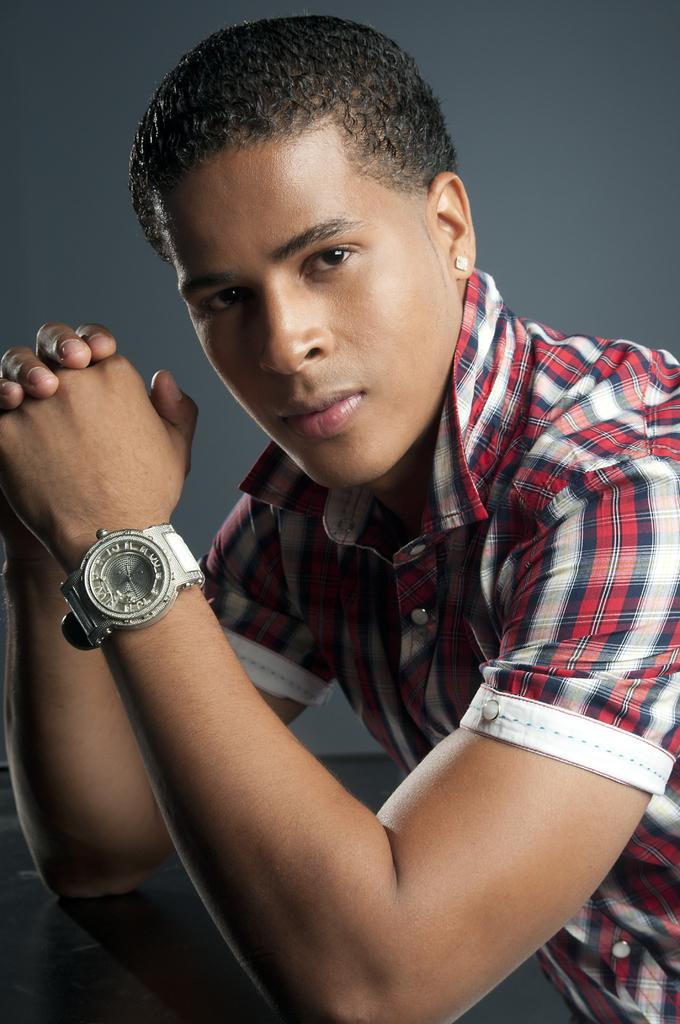What is the primary subject in the image? There is a person sitting in the image. What type of drug is the person using in the image? There is no indication in the image that the person is using any drugs, as the provided fact only mentions that the person is sitting. 